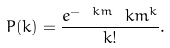<formula> <loc_0><loc_0><loc_500><loc_500>P ( k ) = \frac { e ^ { - \ k m } \ k m ^ { k } } { k ! } .</formula> 